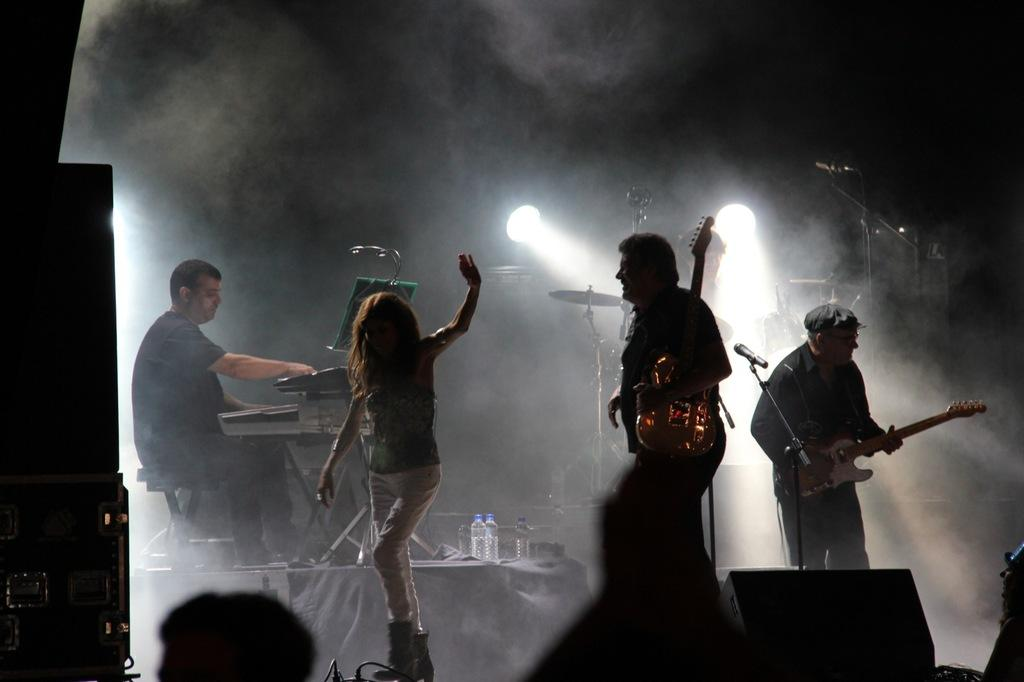How many people are present in the image? There are four people in the image. What are two of the people doing in the image? Two of the people are playing musical instruments. Can you describe any other elements in the image? There is smoke visible in the image. What type of bone is being used as a percussion instrument in the image? There is no bone present in the image, and no instruments are being used as percussion instruments. 